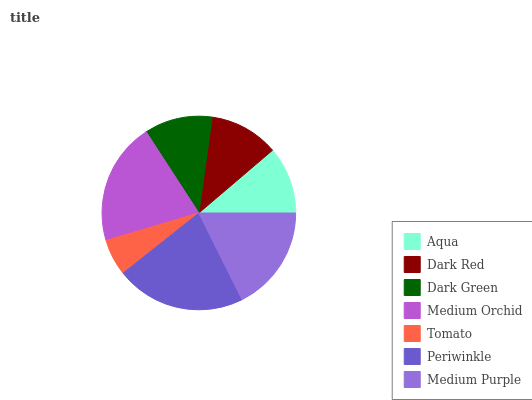Is Tomato the minimum?
Answer yes or no. Yes. Is Periwinkle the maximum?
Answer yes or no. Yes. Is Dark Red the minimum?
Answer yes or no. No. Is Dark Red the maximum?
Answer yes or no. No. Is Dark Red greater than Aqua?
Answer yes or no. Yes. Is Aqua less than Dark Red?
Answer yes or no. Yes. Is Aqua greater than Dark Red?
Answer yes or no. No. Is Dark Red less than Aqua?
Answer yes or no. No. Is Dark Red the high median?
Answer yes or no. Yes. Is Dark Red the low median?
Answer yes or no. Yes. Is Tomato the high median?
Answer yes or no. No. Is Periwinkle the low median?
Answer yes or no. No. 